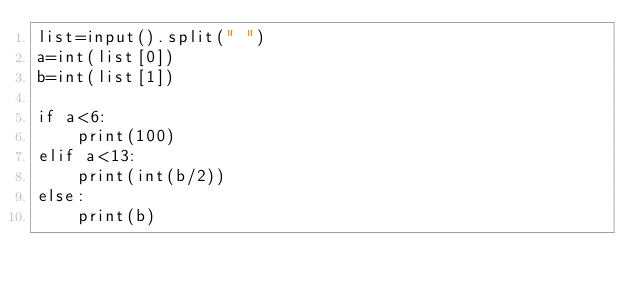Convert code to text. <code><loc_0><loc_0><loc_500><loc_500><_Python_>list=input().split(" ")
a=int(list[0])
b=int(list[1])

if a<6:
    print(100)
elif a<13:
    print(int(b/2))
else:
    print(b)</code> 